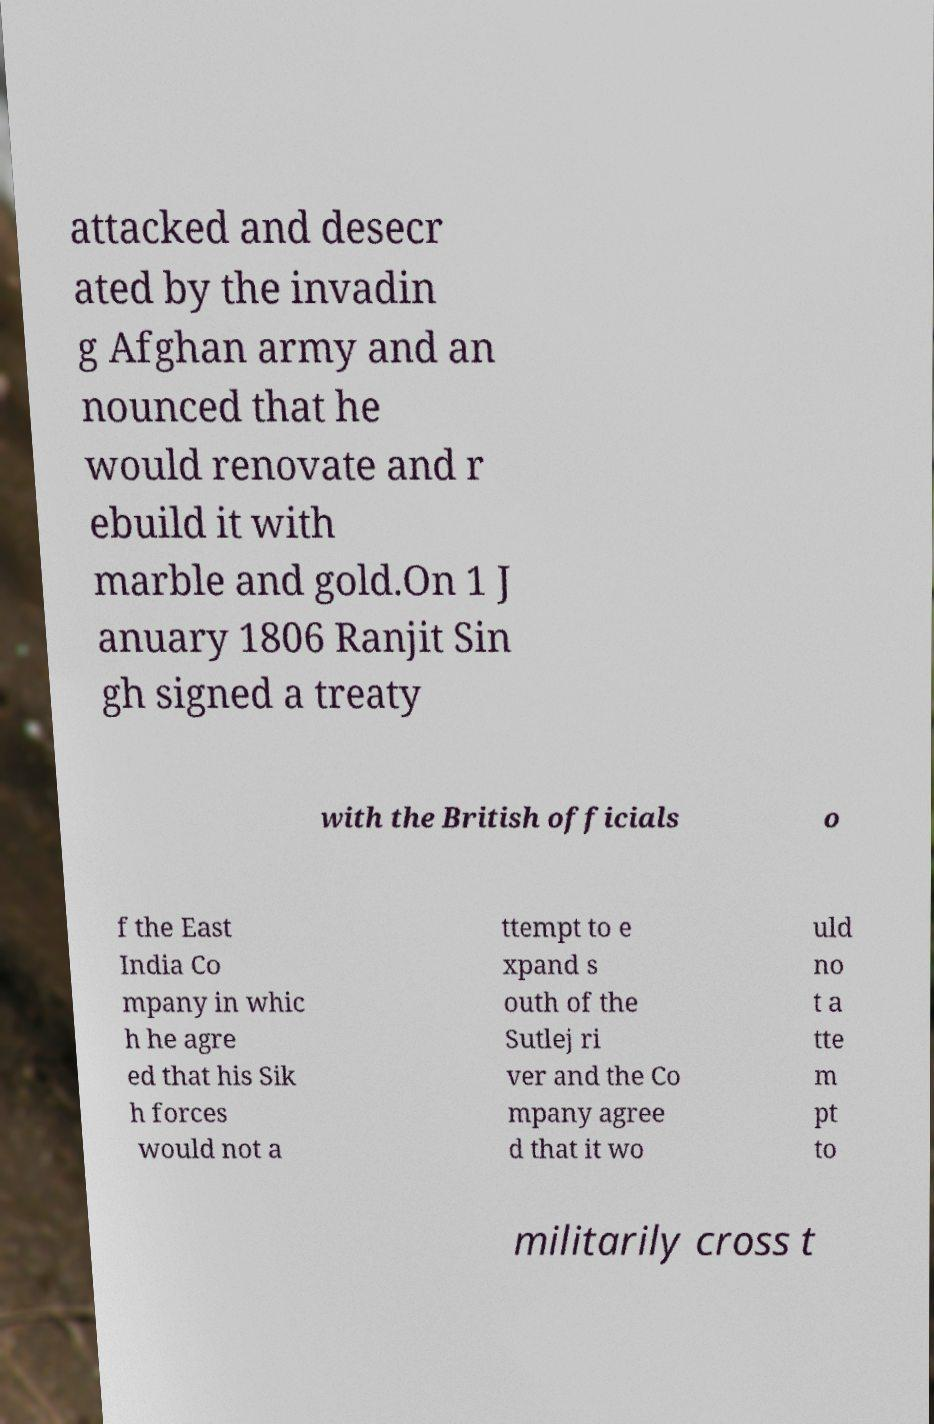Please read and relay the text visible in this image. What does it say? attacked and desecr ated by the invadin g Afghan army and an nounced that he would renovate and r ebuild it with marble and gold.On 1 J anuary 1806 Ranjit Sin gh signed a treaty with the British officials o f the East India Co mpany in whic h he agre ed that his Sik h forces would not a ttempt to e xpand s outh of the Sutlej ri ver and the Co mpany agree d that it wo uld no t a tte m pt to militarily cross t 